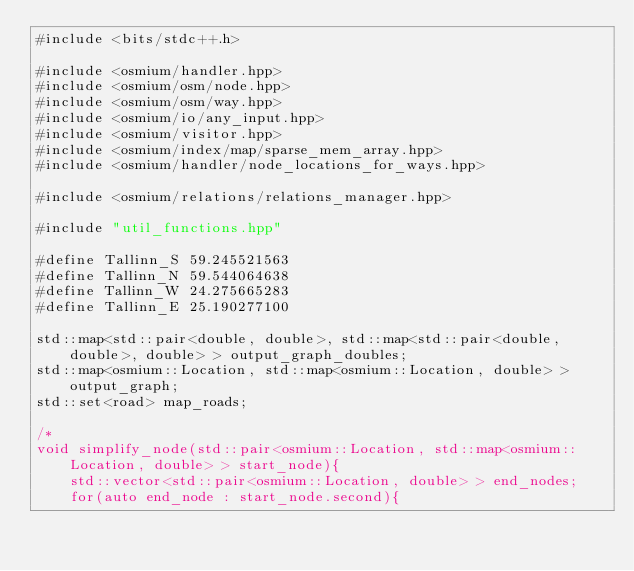Convert code to text. <code><loc_0><loc_0><loc_500><loc_500><_C++_>#include <bits/stdc++.h>

#include <osmium/handler.hpp>
#include <osmium/osm/node.hpp>
#include <osmium/osm/way.hpp>
#include <osmium/io/any_input.hpp>
#include <osmium/visitor.hpp>
#include <osmium/index/map/sparse_mem_array.hpp>
#include <osmium/handler/node_locations_for_ways.hpp>

#include <osmium/relations/relations_manager.hpp>

#include "util_functions.hpp"

#define Tallinn_S 59.245521563
#define Tallinn_N 59.544064638
#define Tallinn_W 24.275665283
#define Tallinn_E 25.190277100

std::map<std::pair<double, double>, std::map<std::pair<double, double>, double> > output_graph_doubles;
std::map<osmium::Location, std::map<osmium::Location, double> > output_graph;
std::set<road> map_roads;
  
/*  
void simplify_node(std::pair<osmium::Location, std::map<osmium::Location, double> > start_node){
	std::vector<std::pair<osmium::Location, double> > end_nodes;  
	for(auto end_node : start_node.second){</code> 